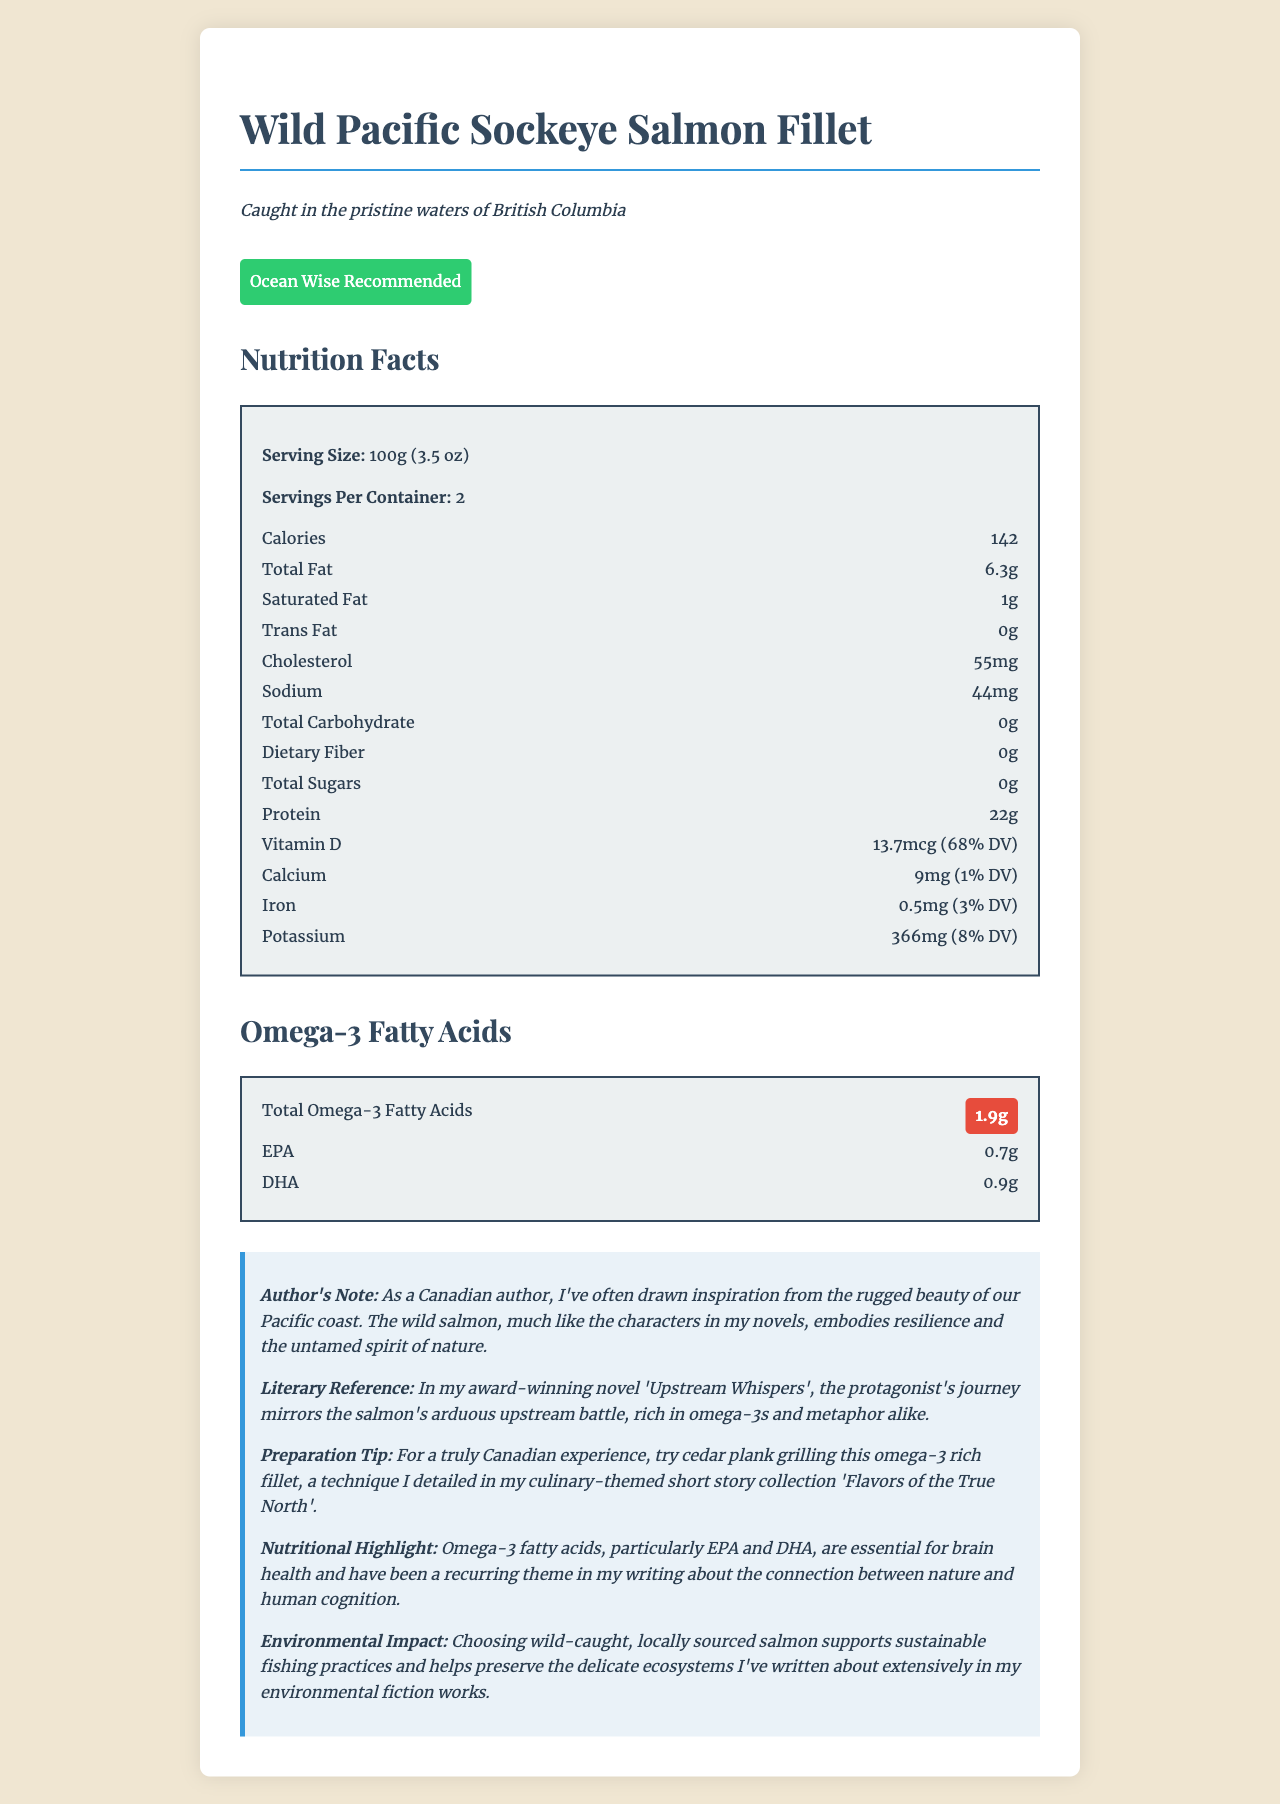what is the serving size of the Wild Pacific Sockeye Salmon Fillet? The document states that the serving size of the Wild Pacific Sockeye Salmon Fillet is 100g (3.5 oz).
Answer: 100g (3.5 oz) How much protein is in one serving of the salmon fillet? The nutrition label indicates that there are 22g of protein per serving of the salmon fillet.
Answer: 22g What is the source of the salmon fillet? The source is mentioned just below the product name and is stated as "Caught in the pristine waters of British Columbia."
Answer: Caught in the pristine waters of British Columbia How much vitamin D does one serving provide, and what percentage of the daily value is this? The nutrition label specifies that one serving provides 13.7mcg of vitamin D, which is 68% of the daily value.
Answer: 13.7mcg (68% DV) What is the sustainability certification of the salmon fillet? The document mentions that the sustainability certification of the salmon fillet is "Ocean Wise Recommended."
Answer: Ocean Wise Recommended This salmon fillet can be prepared using a Canadian technique. What is the technique? The preparation tip in the author's note mentions cedar plank grilling as a technique for a truly Canadian experience.
Answer: Cedar plank grilling How much omega-3 fatty acids are in one serving of the salmon fillet? The document highlights that one serving contains 1.9g of omega-3 fatty acids.
Answer: 1.9g Is there any trans fat in one serving of the salmon fillet? The nutrition label shows that there are 0g of trans fat in one serving.
Answer: No How many milligrams of sodium are in one serving of the salmon fillet? The nutrition label indicates that one serving contains 44mg of sodium.
Answer: 44mg How many servings per container are there? The document specifies that there are 2 servings per container.
Answer: 2  The nutrition label shows that protein is present in the highest amount (22g) compared to calcium (9mg), iron (0.5mg), and potassium (366mg).
Answer: D. Protein  The author's note mentions that omega-3 fatty acids are essential for brain health and this theme has been recurring in the author's writing.
Answer: I. Brain health Is the Wild Pacific Sockeye Salmon Fillet a good source of dietary fiber? The nutrition label indicates that there is 0g of dietary fiber in the salmon fillet.
Answer: No Summarize the main features of the Wild Pacific Sockeye Salmon Fillet according to the document. The summary captures the key points from the document, including the source, sustainability certification, nutritional highlights, preparation tip, and the environmental impact.
Answer: The Wild Pacific Sockeye Salmon Fillet is a nutrient-dense fish caught in the pristine waters of British Columbia with a sustainability certification of Ocean Wise Recommended. It provides significant amounts of protein and omega-3 fatty acids (particularly EPA and DHA) and is rich in vitamin D. The fillet can be prepared using cedar plank grilling for a Canadian experience. It supports brain health and sustainable fishing practices. What other types of fish are featured in the author's culinary-themed short story collection 'Flavors of the True North'? The document does not provide information about other types of fish featured in the author's short story collection.
Answer: Cannot be determined 